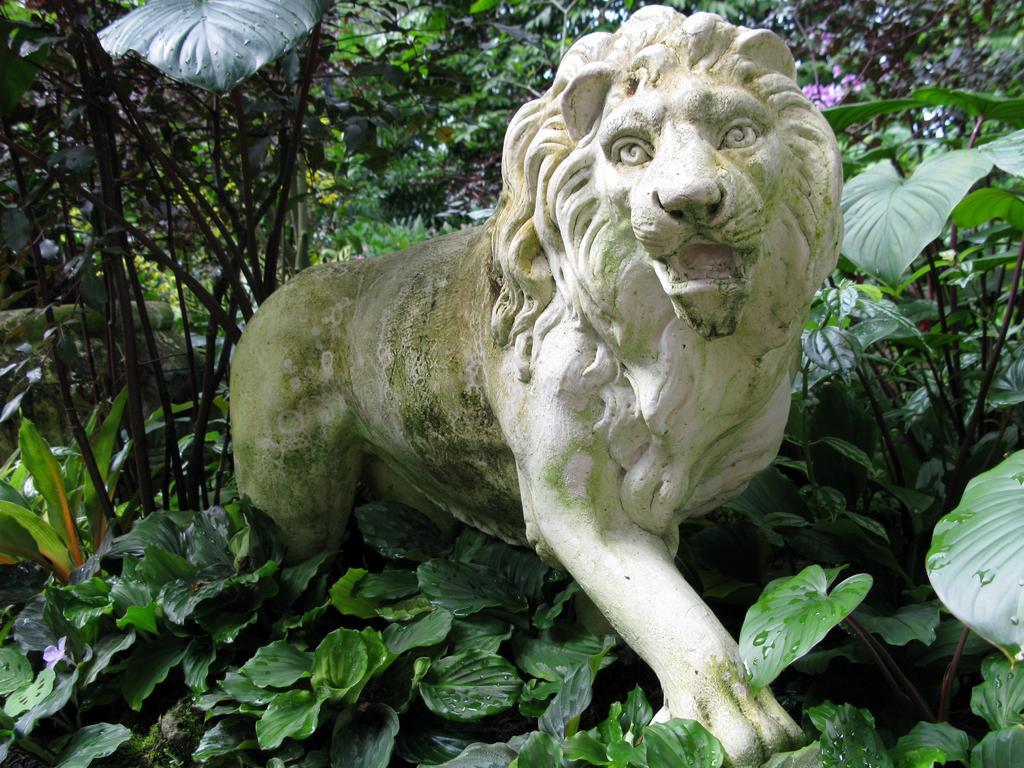What is the main subject of the image? There is a statue of a lion in the image. What color is the statue? The statue is white in color. What can be seen in the background of the image? There are plants and trees in the background of the image. How many balls are being held by the lion statue in the image? There are no balls present in the image, as the main subject is a statue of a lion without any additional objects. 